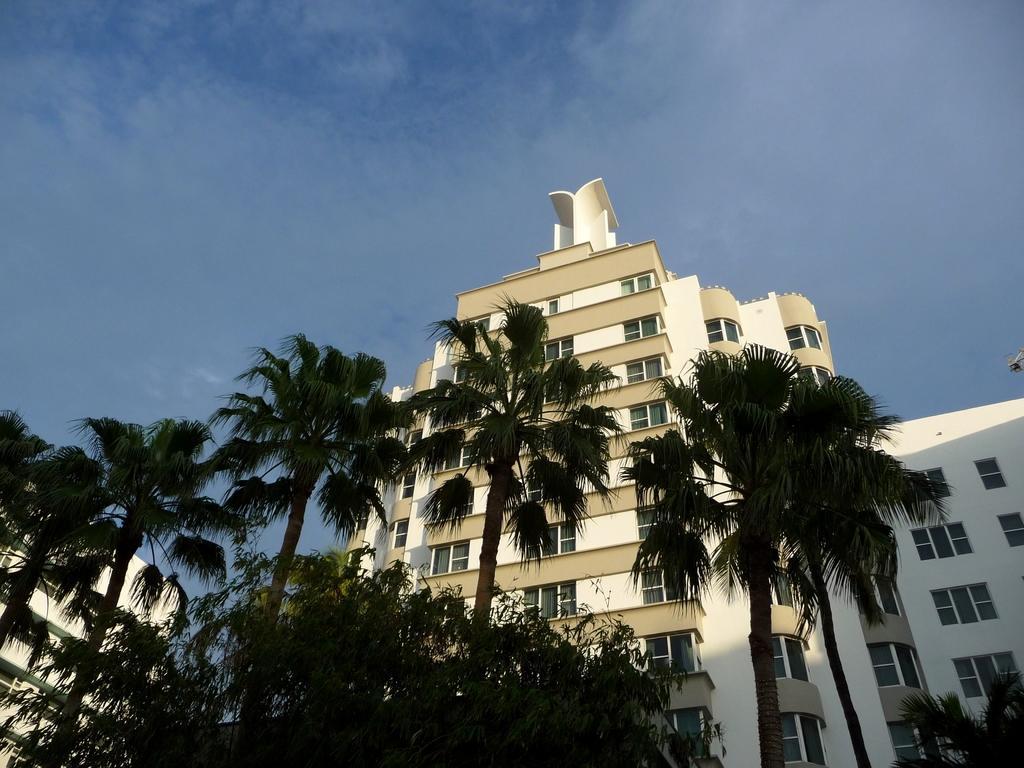In one or two sentences, can you explain what this image depicts? In foreground we can see some trees over here. On the right side we can see one building. In middle of the image we can see some tall trees and building which is in white and cream color. At the top we can see a blue sky. 